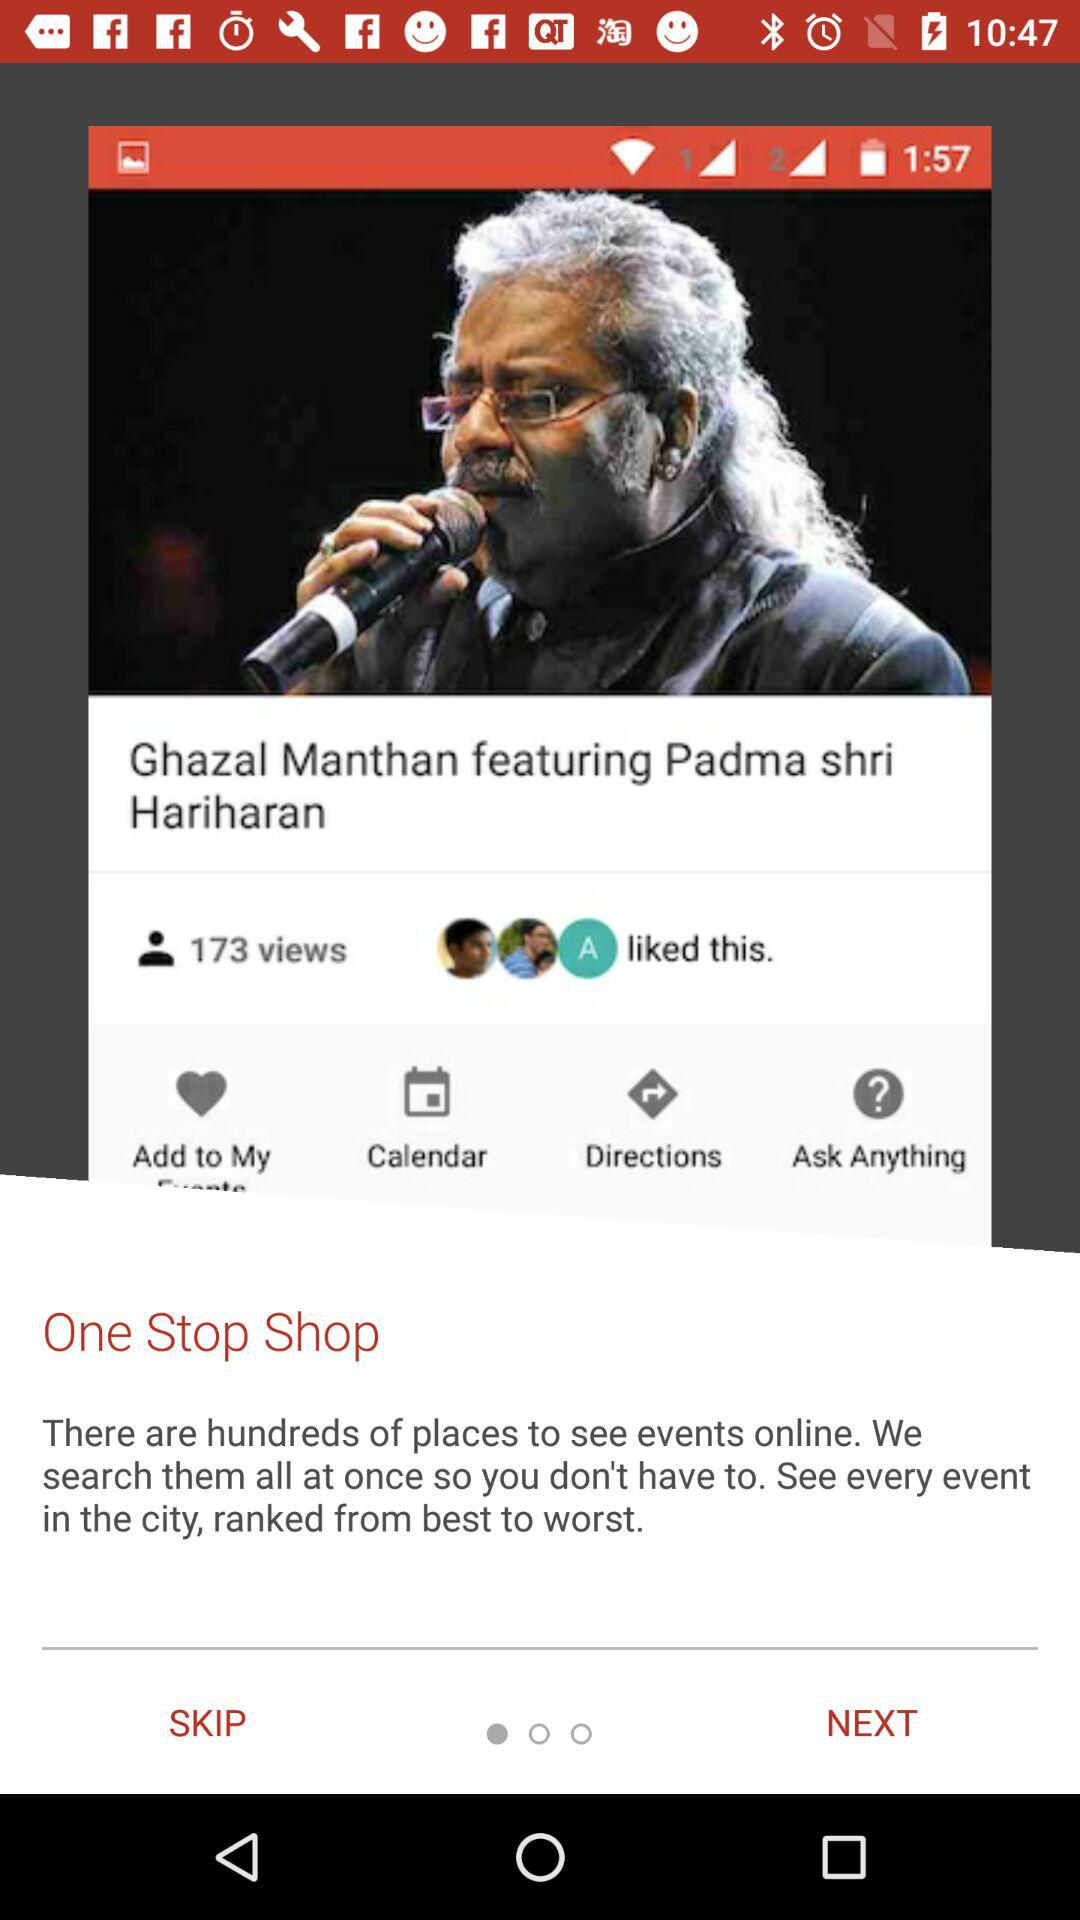What is the headline of the post? The headline of the post is "Ghazal Manthan featuring Padma shri Hariharan". 